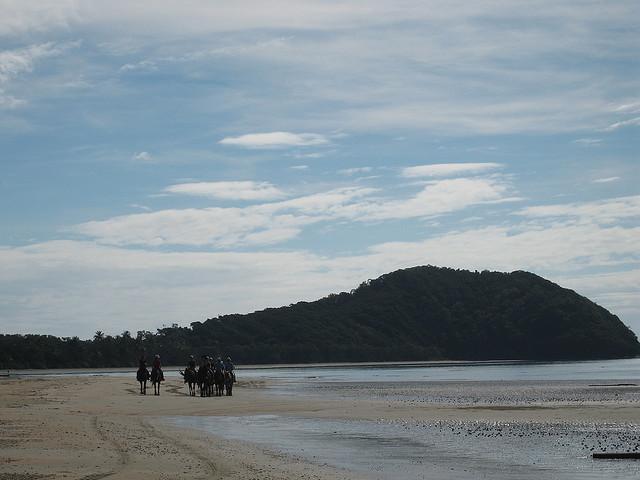How many elephants are behind the fence?
Give a very brief answer. 0. 